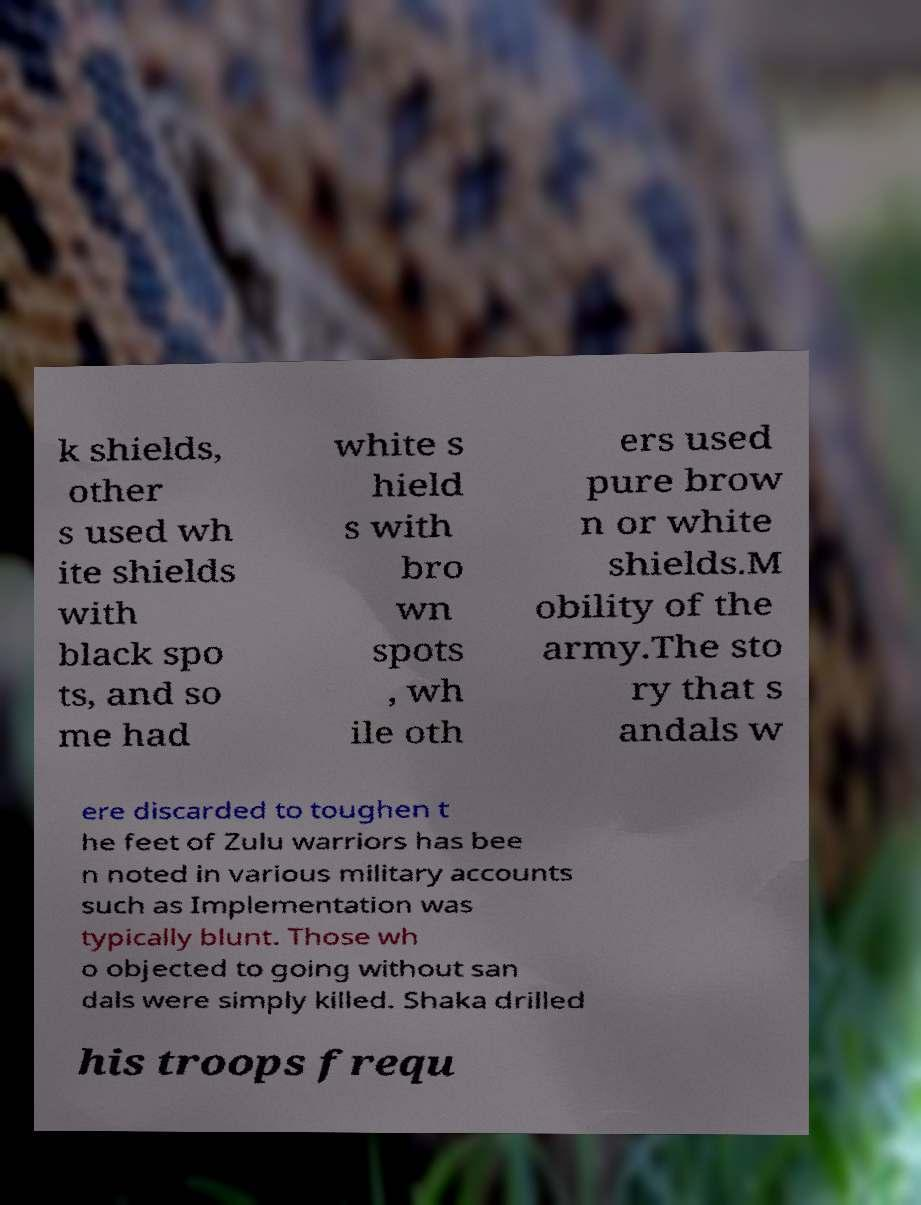Please identify and transcribe the text found in this image. k shields, other s used wh ite shields with black spo ts, and so me had white s hield s with bro wn spots , wh ile oth ers used pure brow n or white shields.M obility of the army.The sto ry that s andals w ere discarded to toughen t he feet of Zulu warriors has bee n noted in various military accounts such as Implementation was typically blunt. Those wh o objected to going without san dals were simply killed. Shaka drilled his troops frequ 